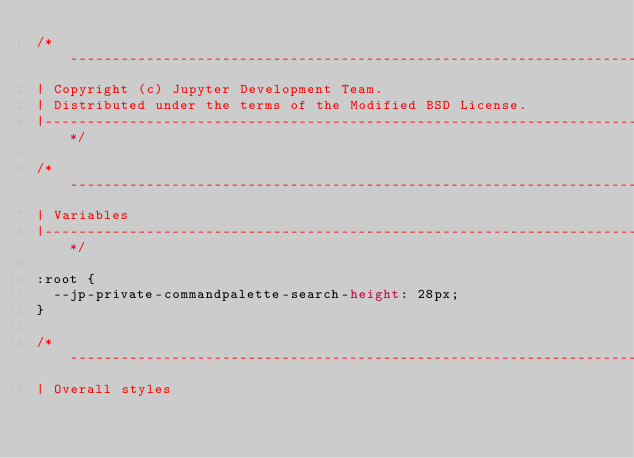Convert code to text. <code><loc_0><loc_0><loc_500><loc_500><_CSS_>/*-----------------------------------------------------------------------------
| Copyright (c) Jupyter Development Team.
| Distributed under the terms of the Modified BSD License.
|----------------------------------------------------------------------------*/

/*-----------------------------------------------------------------------------
| Variables
|----------------------------------------------------------------------------*/

:root {
  --jp-private-commandpalette-search-height: 28px;
}

/*-----------------------------------------------------------------------------
| Overall styles</code> 